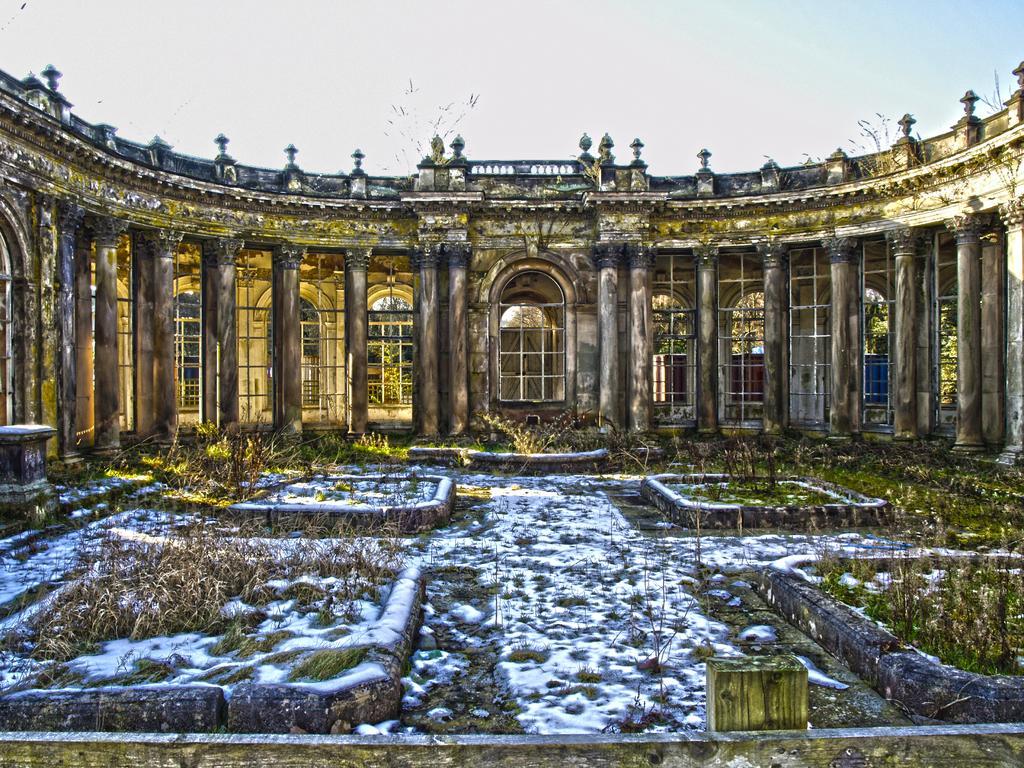Please provide a concise description of this image. This is an animated image. At the bottom of the image on the ground there is grass and also there are blocks like things. There is a building with walls, windows, arches, pillars and railings. At the top of the image there is sky. 